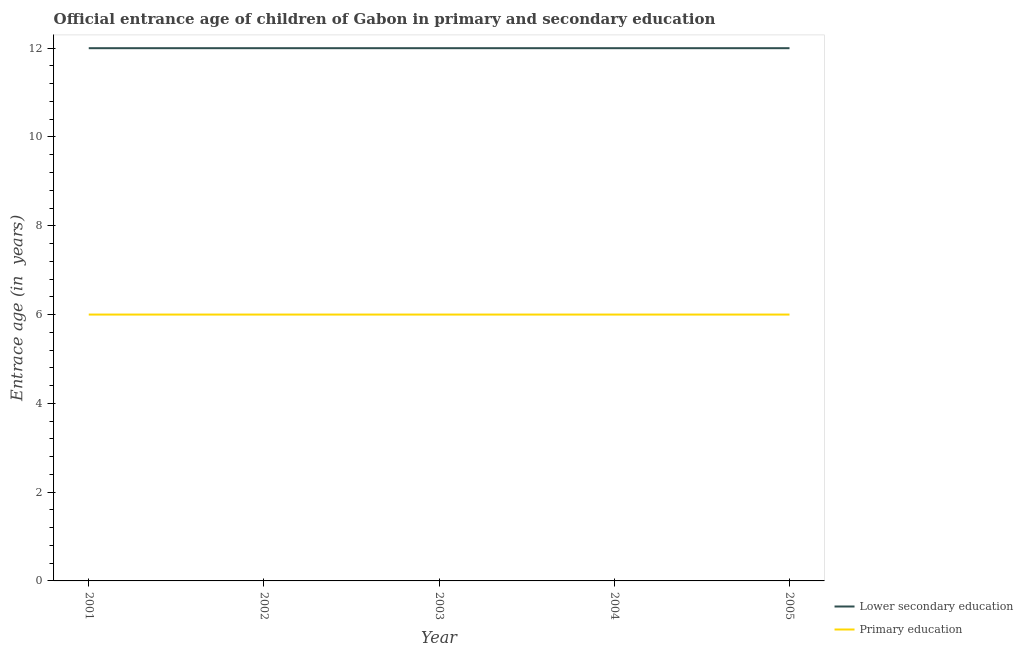How many different coloured lines are there?
Your answer should be compact. 2. Does the line corresponding to entrance age of children in lower secondary education intersect with the line corresponding to entrance age of chiildren in primary education?
Your response must be concise. No. Is the number of lines equal to the number of legend labels?
Provide a succinct answer. Yes. What is the entrance age of children in lower secondary education in 2002?
Your response must be concise. 12. Across all years, what is the maximum entrance age of chiildren in primary education?
Make the answer very short. 6. In which year was the entrance age of chiildren in primary education maximum?
Provide a succinct answer. 2001. In which year was the entrance age of chiildren in primary education minimum?
Provide a succinct answer. 2001. What is the total entrance age of children in lower secondary education in the graph?
Your answer should be compact. 60. What is the difference between the entrance age of chiildren in primary education in 2003 and the entrance age of children in lower secondary education in 2001?
Provide a short and direct response. -6. In the year 2003, what is the difference between the entrance age of chiildren in primary education and entrance age of children in lower secondary education?
Your answer should be compact. -6. What is the ratio of the entrance age of children in lower secondary education in 2003 to that in 2004?
Ensure brevity in your answer.  1. Is the difference between the entrance age of chiildren in primary education in 2002 and 2005 greater than the difference between the entrance age of children in lower secondary education in 2002 and 2005?
Provide a succinct answer. No. What is the difference between the highest and the lowest entrance age of chiildren in primary education?
Keep it short and to the point. 0. In how many years, is the entrance age of chiildren in primary education greater than the average entrance age of chiildren in primary education taken over all years?
Your answer should be very brief. 0. Does the entrance age of children in lower secondary education monotonically increase over the years?
Ensure brevity in your answer.  No. How many lines are there?
Your answer should be very brief. 2. Does the graph contain any zero values?
Provide a succinct answer. No. How are the legend labels stacked?
Keep it short and to the point. Vertical. What is the title of the graph?
Make the answer very short. Official entrance age of children of Gabon in primary and secondary education. What is the label or title of the Y-axis?
Your answer should be very brief. Entrace age (in  years). What is the Entrace age (in  years) in Lower secondary education in 2003?
Offer a very short reply. 12. What is the Entrace age (in  years) in Primary education in 2003?
Make the answer very short. 6. What is the Entrace age (in  years) of Lower secondary education in 2004?
Your response must be concise. 12. What is the total Entrace age (in  years) of Primary education in the graph?
Provide a short and direct response. 30. What is the difference between the Entrace age (in  years) of Lower secondary education in 2001 and that in 2002?
Keep it short and to the point. 0. What is the difference between the Entrace age (in  years) of Lower secondary education in 2001 and that in 2003?
Provide a succinct answer. 0. What is the difference between the Entrace age (in  years) in Primary education in 2001 and that in 2004?
Your response must be concise. 0. What is the difference between the Entrace age (in  years) of Lower secondary education in 2002 and that in 2003?
Provide a short and direct response. 0. What is the difference between the Entrace age (in  years) in Primary education in 2002 and that in 2003?
Your response must be concise. 0. What is the difference between the Entrace age (in  years) of Lower secondary education in 2002 and that in 2004?
Keep it short and to the point. 0. What is the difference between the Entrace age (in  years) in Primary education in 2002 and that in 2005?
Give a very brief answer. 0. What is the difference between the Entrace age (in  years) in Lower secondary education in 2003 and that in 2004?
Offer a terse response. 0. What is the difference between the Entrace age (in  years) in Primary education in 2003 and that in 2004?
Provide a short and direct response. 0. What is the difference between the Entrace age (in  years) in Lower secondary education in 2003 and that in 2005?
Keep it short and to the point. 0. What is the difference between the Entrace age (in  years) in Primary education in 2003 and that in 2005?
Offer a very short reply. 0. What is the difference between the Entrace age (in  years) in Primary education in 2004 and that in 2005?
Your answer should be very brief. 0. What is the difference between the Entrace age (in  years) of Lower secondary education in 2001 and the Entrace age (in  years) of Primary education in 2004?
Give a very brief answer. 6. What is the difference between the Entrace age (in  years) of Lower secondary education in 2001 and the Entrace age (in  years) of Primary education in 2005?
Provide a short and direct response. 6. What is the difference between the Entrace age (in  years) in Lower secondary education in 2002 and the Entrace age (in  years) in Primary education in 2004?
Keep it short and to the point. 6. What is the difference between the Entrace age (in  years) of Lower secondary education in 2002 and the Entrace age (in  years) of Primary education in 2005?
Provide a short and direct response. 6. What is the average Entrace age (in  years) in Lower secondary education per year?
Provide a short and direct response. 12. What is the average Entrace age (in  years) of Primary education per year?
Provide a short and direct response. 6. In the year 2001, what is the difference between the Entrace age (in  years) of Lower secondary education and Entrace age (in  years) of Primary education?
Your answer should be compact. 6. In the year 2003, what is the difference between the Entrace age (in  years) in Lower secondary education and Entrace age (in  years) in Primary education?
Offer a terse response. 6. In the year 2004, what is the difference between the Entrace age (in  years) in Lower secondary education and Entrace age (in  years) in Primary education?
Ensure brevity in your answer.  6. What is the ratio of the Entrace age (in  years) in Lower secondary education in 2001 to that in 2002?
Offer a very short reply. 1. What is the ratio of the Entrace age (in  years) of Lower secondary education in 2001 to that in 2003?
Offer a very short reply. 1. What is the ratio of the Entrace age (in  years) of Primary education in 2001 to that in 2004?
Keep it short and to the point. 1. What is the ratio of the Entrace age (in  years) of Lower secondary education in 2001 to that in 2005?
Provide a short and direct response. 1. What is the ratio of the Entrace age (in  years) in Primary education in 2001 to that in 2005?
Offer a very short reply. 1. What is the ratio of the Entrace age (in  years) of Lower secondary education in 2002 to that in 2004?
Ensure brevity in your answer.  1. What is the ratio of the Entrace age (in  years) of Lower secondary education in 2003 to that in 2004?
Give a very brief answer. 1. What is the ratio of the Entrace age (in  years) of Lower secondary education in 2003 to that in 2005?
Your answer should be very brief. 1. What is the ratio of the Entrace age (in  years) of Primary education in 2003 to that in 2005?
Ensure brevity in your answer.  1. What is the ratio of the Entrace age (in  years) in Lower secondary education in 2004 to that in 2005?
Your answer should be very brief. 1. What is the difference between the highest and the second highest Entrace age (in  years) of Lower secondary education?
Provide a short and direct response. 0. What is the difference between the highest and the second highest Entrace age (in  years) in Primary education?
Offer a terse response. 0. What is the difference between the highest and the lowest Entrace age (in  years) in Lower secondary education?
Provide a succinct answer. 0. 